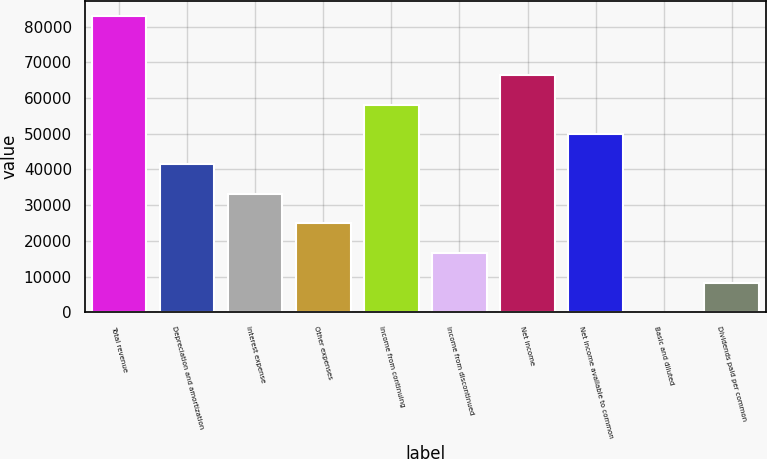<chart> <loc_0><loc_0><loc_500><loc_500><bar_chart><fcel>Total revenue<fcel>Depreciation and amortization<fcel>Interest expense<fcel>Other expenses<fcel>Income from continuing<fcel>Income from discontinued<fcel>Net income<fcel>Net income available to common<fcel>Basic and diluted<fcel>Dividends paid per common<nl><fcel>83047<fcel>41523.6<fcel>33219<fcel>24914.3<fcel>58133<fcel>16609.6<fcel>66437.7<fcel>49828.3<fcel>0.24<fcel>8304.92<nl></chart> 